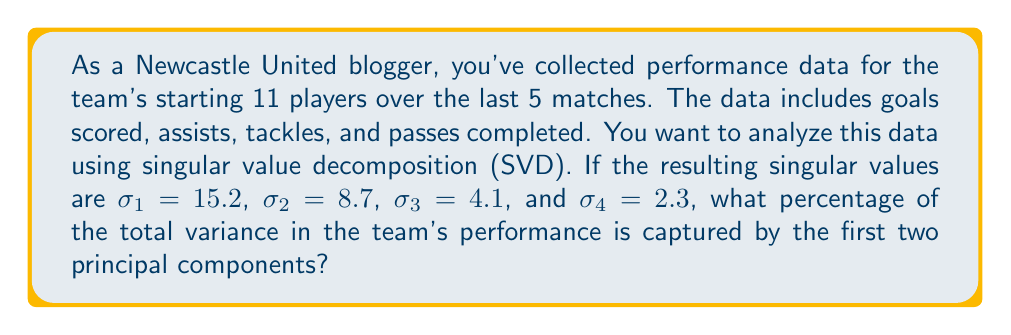Could you help me with this problem? To solve this problem, we'll follow these steps:

1) In SVD, the singular values represent the importance of each component in capturing the variance of the data. The larger the singular value, the more important the component.

2) The total variance in the data is proportional to the sum of the squares of all singular values. Let's call this sum $S$:

   $$S = \sigma_1^2 + \sigma_2^2 + \sigma_3^2 + \sigma_4^2$$

3) Calculate $S$:
   $$S = 15.2^2 + 8.7^2 + 4.1^2 + 2.3^2 = 231.04 + 75.69 + 16.81 + 5.29 = 328.83$$

4) The variance captured by the first two principal components is proportional to the sum of the squares of the first two singular values. Let's call this $S_2$:

   $$S_2 = \sigma_1^2 + \sigma_2^2 = 15.2^2 + 8.7^2 = 231.04 + 75.69 = 306.73$$

5) The percentage of variance captured by the first two components is:

   $$\text{Percentage} = \frac{S_2}{S} \times 100\% = \frac{306.73}{328.83} \times 100\% \approx 93.28\%$$

Therefore, the first two principal components capture approximately 93.28% of the total variance in Newcastle United's performance data.
Answer: 93.28% 